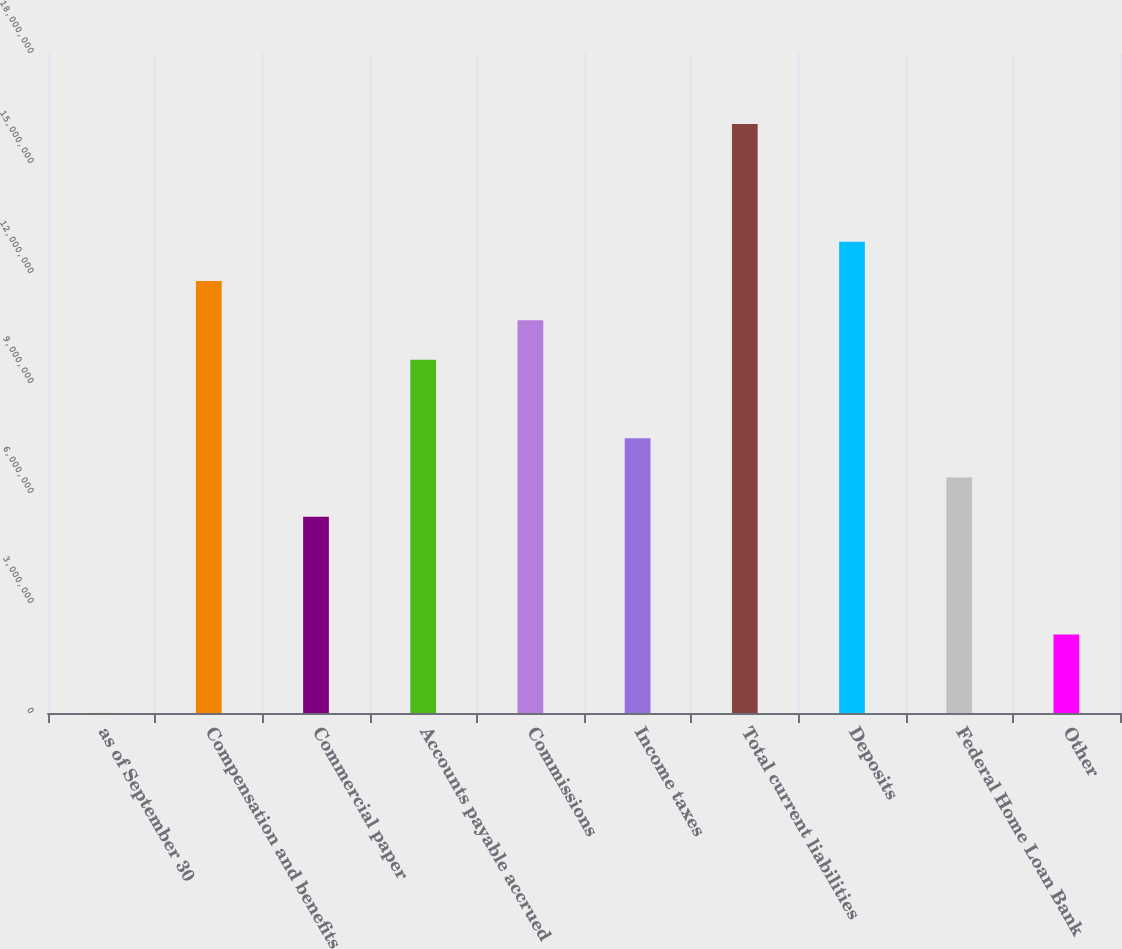Convert chart. <chart><loc_0><loc_0><loc_500><loc_500><bar_chart><fcel>as of September 30<fcel>Compensation and benefits<fcel>Commercial paper<fcel>Accounts payable accrued<fcel>Commissions<fcel>Income taxes<fcel>Total current liabilities<fcel>Deposits<fcel>Federal Home Loan Bank<fcel>Other<nl><fcel>2010<fcel>1.17787e+07<fcel>5.35505e+06<fcel>9.63748e+06<fcel>1.07081e+07<fcel>7.49626e+06<fcel>1.60611e+07<fcel>1.28493e+07<fcel>6.42566e+06<fcel>2.14323e+06<nl></chart> 